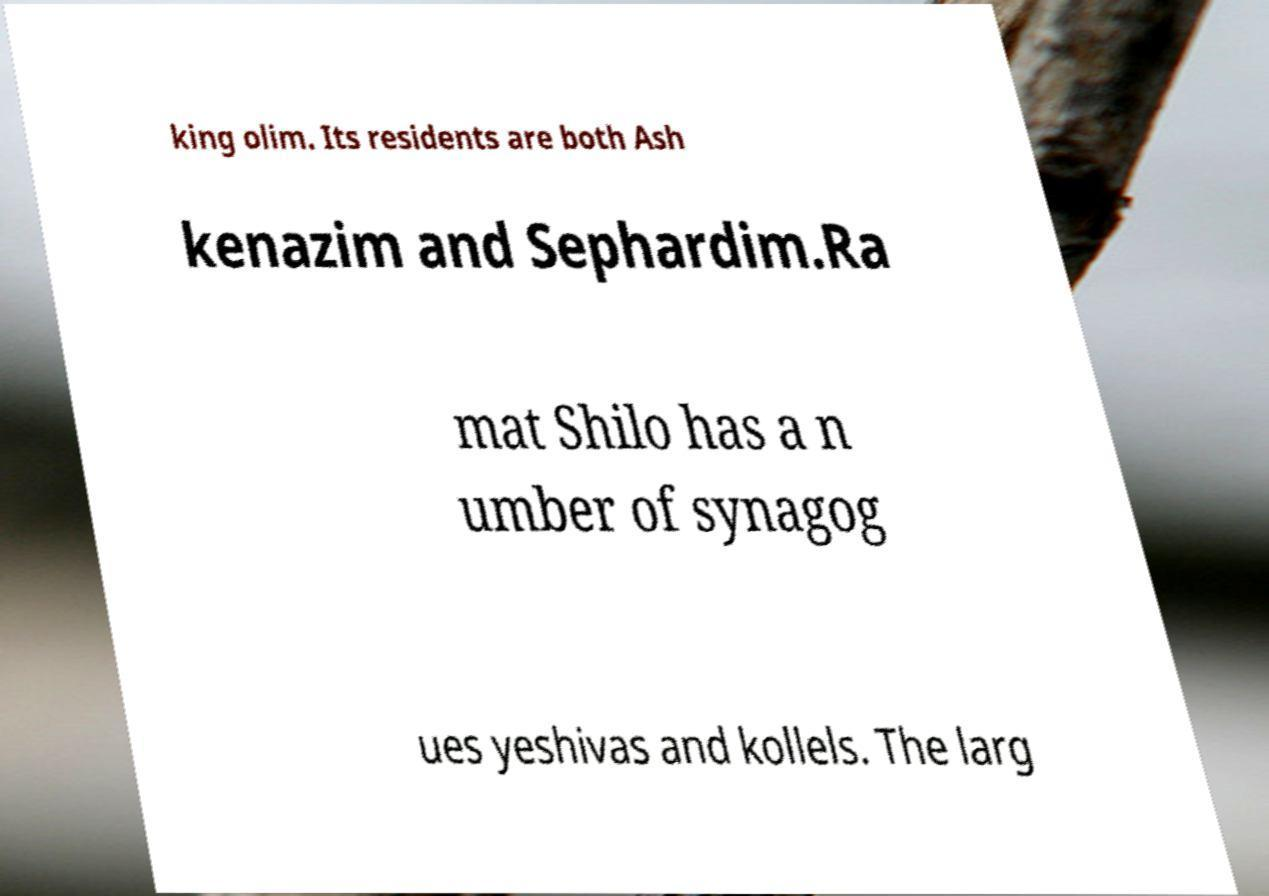I need the written content from this picture converted into text. Can you do that? king olim. Its residents are both Ash kenazim and Sephardim.Ra mat Shilo has a n umber of synagog ues yeshivas and kollels. The larg 